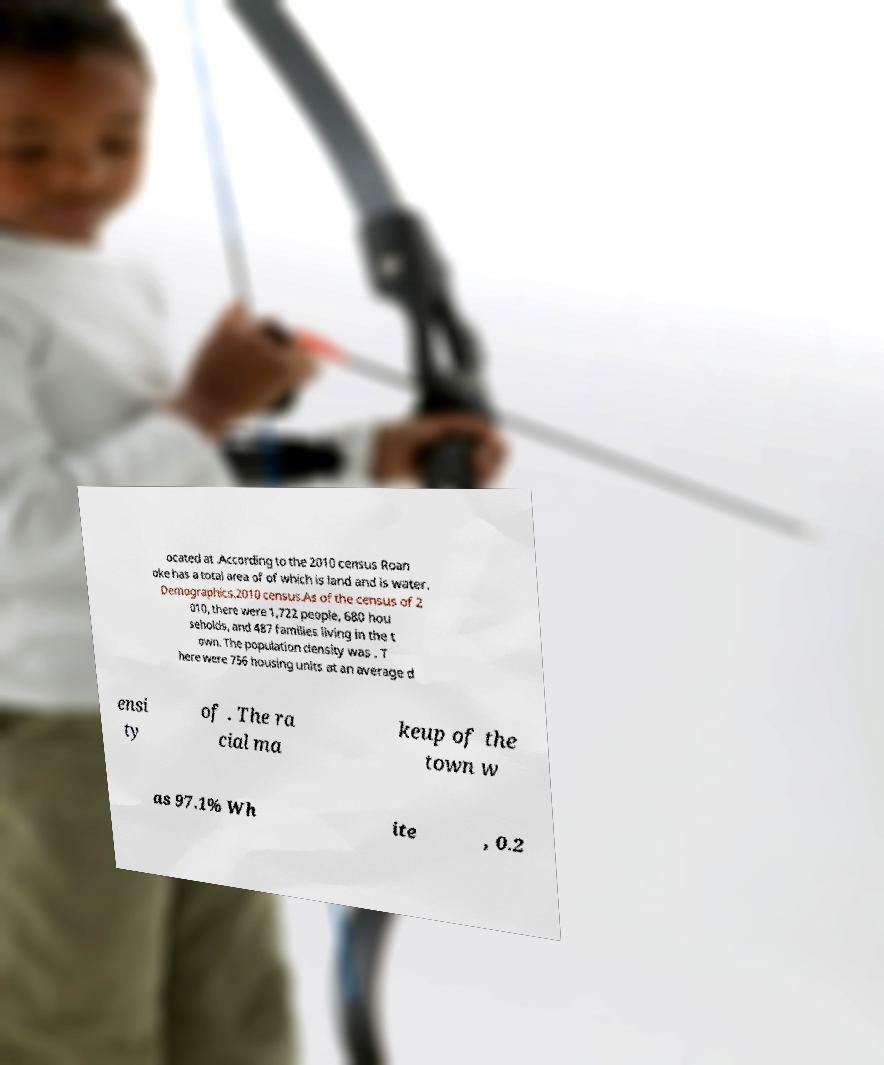Can you read and provide the text displayed in the image?This photo seems to have some interesting text. Can you extract and type it out for me? ocated at .According to the 2010 census Roan oke has a total area of of which is land and is water. Demographics.2010 census.As of the census of 2 010, there were 1,722 people, 680 hou seholds, and 487 families living in the t own. The population density was . T here were 756 housing units at an average d ensi ty of . The ra cial ma keup of the town w as 97.1% Wh ite , 0.2 